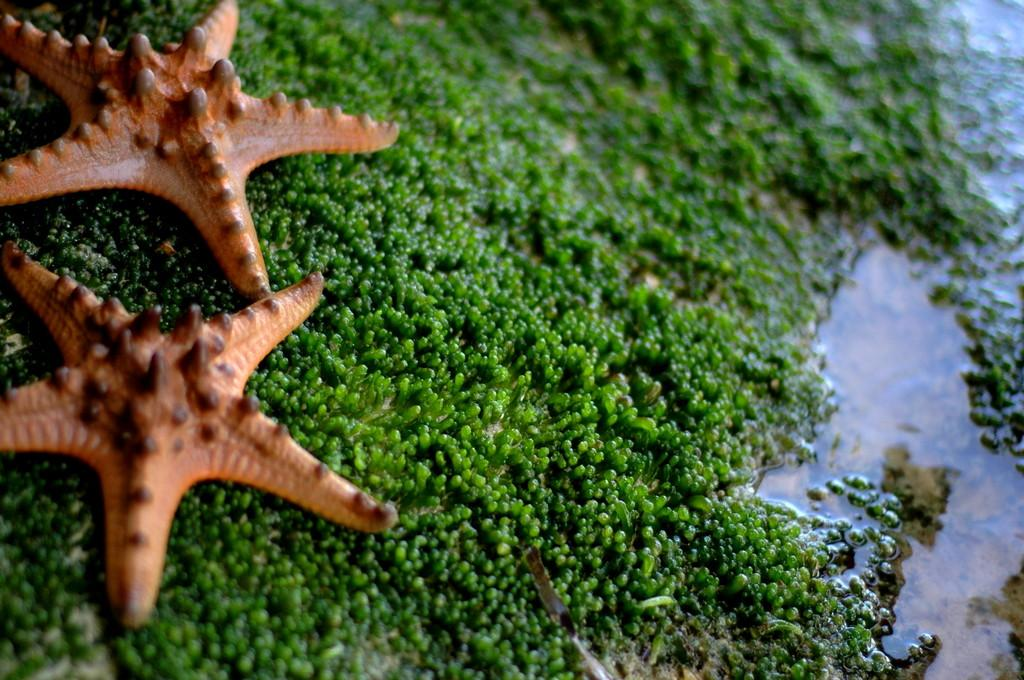What animals are present in the image? There are two starfishes in the picture. What surface are the starfishes resting on? The starfishes are on a green object. What can be seen in the right corner of the image? There is water visible in the right corner of the image. What type of book is the goat reading in the image? There is no goat or book present in the image; it features two starfishes on a green object with water visible in the right corner. 